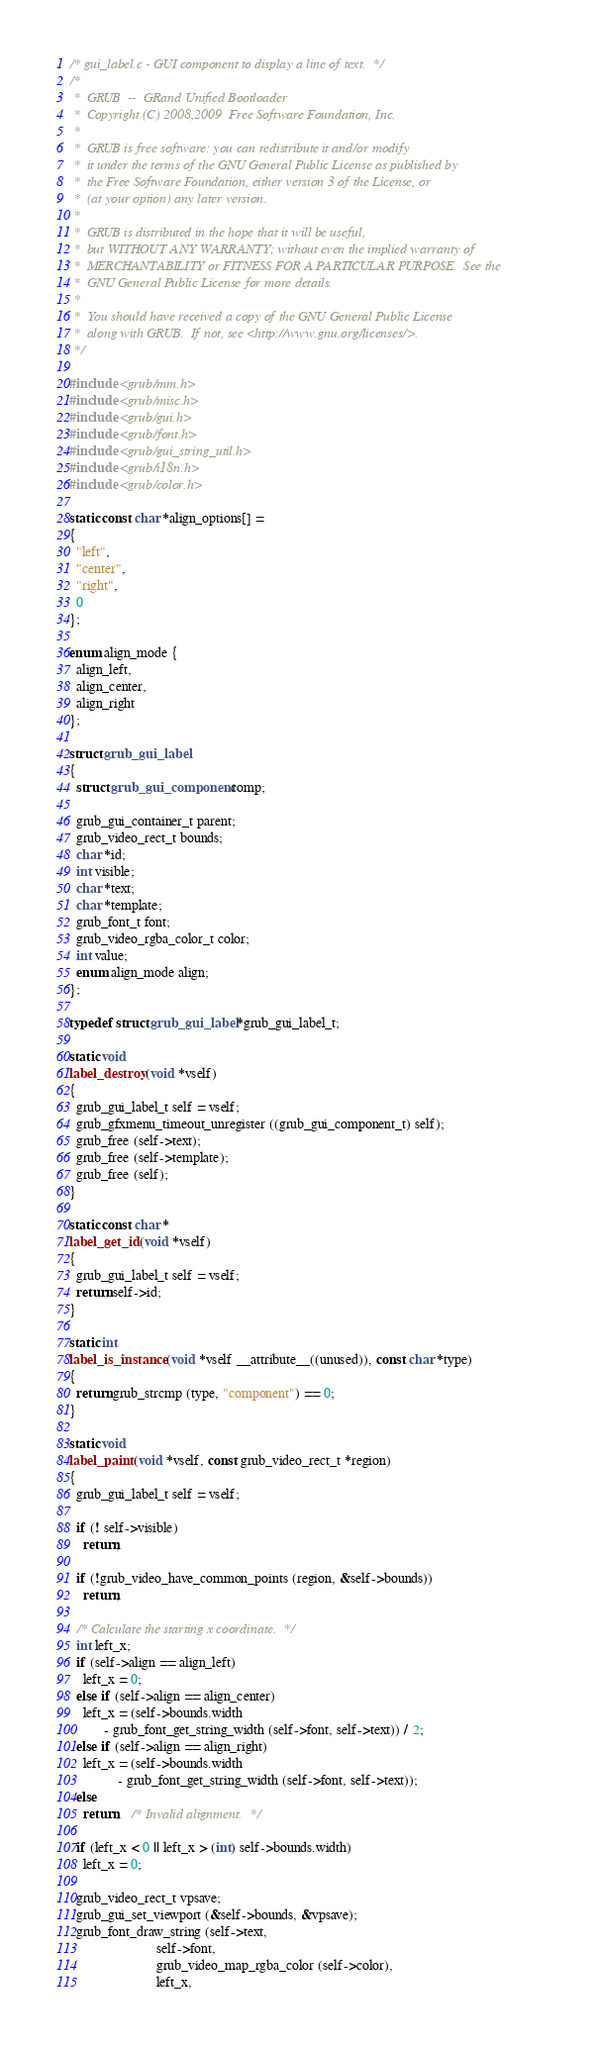Convert code to text. <code><loc_0><loc_0><loc_500><loc_500><_C_>/* gui_label.c - GUI component to display a line of text.  */
/*
 *  GRUB  --  GRand Unified Bootloader
 *  Copyright (C) 2008,2009  Free Software Foundation, Inc.
 *
 *  GRUB is free software: you can redistribute it and/or modify
 *  it under the terms of the GNU General Public License as published by
 *  the Free Software Foundation, either version 3 of the License, or
 *  (at your option) any later version.
 *
 *  GRUB is distributed in the hope that it will be useful,
 *  but WITHOUT ANY WARRANTY; without even the implied warranty of
 *  MERCHANTABILITY or FITNESS FOR A PARTICULAR PURPOSE.  See the
 *  GNU General Public License for more details.
 *
 *  You should have received a copy of the GNU General Public License
 *  along with GRUB.  If not, see <http://www.gnu.org/licenses/>.
 */

#include <grub/mm.h>
#include <grub/misc.h>
#include <grub/gui.h>
#include <grub/font.h>
#include <grub/gui_string_util.h>
#include <grub/i18n.h>
#include <grub/color.h>

static const char *align_options[] =
{
  "left",
  "center",
  "right",
  0
};

enum align_mode {
  align_left,
  align_center,
  align_right
};

struct grub_gui_label
{
  struct grub_gui_component comp;

  grub_gui_container_t parent;
  grub_video_rect_t bounds;
  char *id;
  int visible;
  char *text;
  char *template;
  grub_font_t font;
  grub_video_rgba_color_t color;
  int value;
  enum align_mode align;
};

typedef struct grub_gui_label *grub_gui_label_t;

static void
label_destroy (void *vself)
{
  grub_gui_label_t self = vself;
  grub_gfxmenu_timeout_unregister ((grub_gui_component_t) self);
  grub_free (self->text);
  grub_free (self->template);
  grub_free (self);
}

static const char *
label_get_id (void *vself)
{
  grub_gui_label_t self = vself;
  return self->id;
}

static int
label_is_instance (void *vself __attribute__((unused)), const char *type)
{
  return grub_strcmp (type, "component") == 0;
}

static void
label_paint (void *vself, const grub_video_rect_t *region)
{
  grub_gui_label_t self = vself;

  if (! self->visible)
    return;

  if (!grub_video_have_common_points (region, &self->bounds))
    return;

  /* Calculate the starting x coordinate.  */
  int left_x;
  if (self->align == align_left)
    left_x = 0;
  else if (self->align == align_center)
    left_x = (self->bounds.width
	      - grub_font_get_string_width (self->font, self->text)) / 2;
  else if (self->align == align_right)
    left_x = (self->bounds.width
              - grub_font_get_string_width (self->font, self->text));
  else
    return;   /* Invalid alignment.  */

  if (left_x < 0 || left_x > (int) self->bounds.width)
    left_x = 0;

  grub_video_rect_t vpsave;
  grub_gui_set_viewport (&self->bounds, &vpsave);
  grub_font_draw_string (self->text,
                         self->font,
                         grub_video_map_rgba_color (self->color),
                         left_x,</code> 